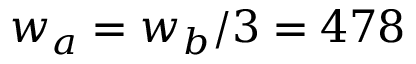Convert formula to latex. <formula><loc_0><loc_0><loc_500><loc_500>w _ { a } = w _ { b } / 3 = 4 7 8</formula> 